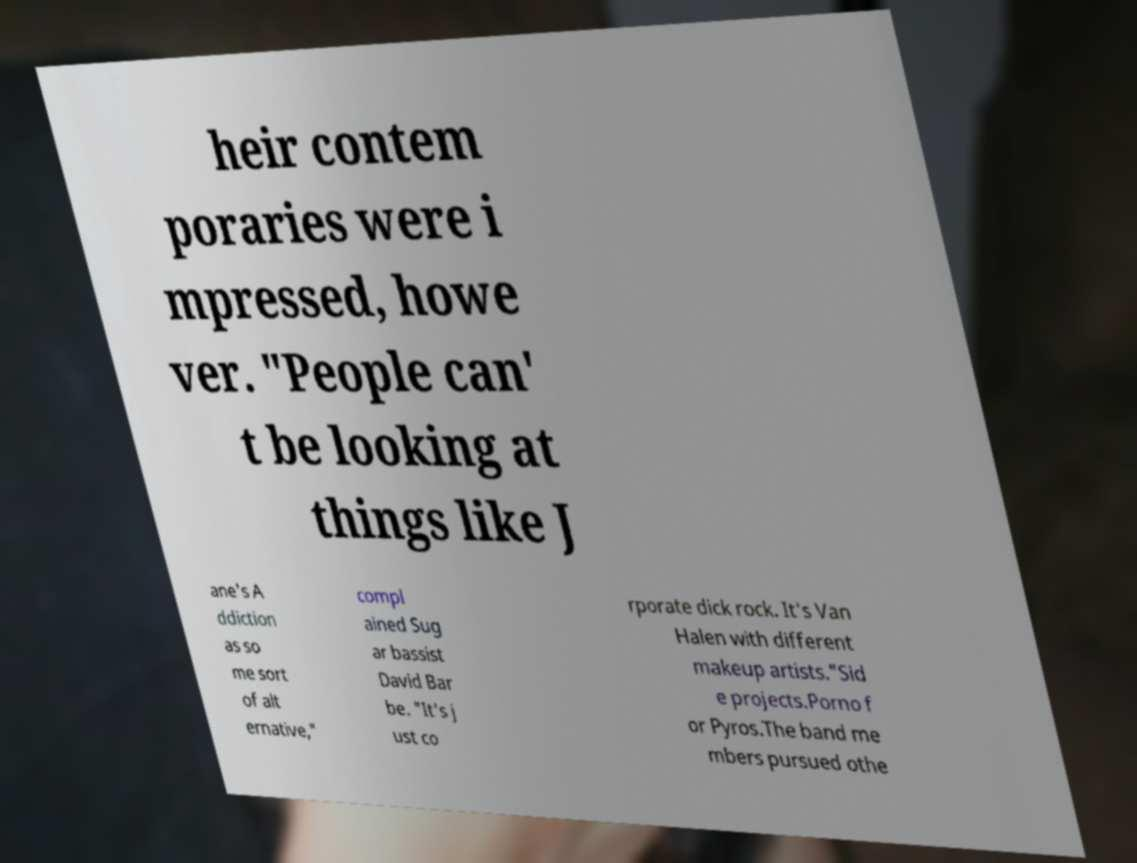There's text embedded in this image that I need extracted. Can you transcribe it verbatim? heir contem poraries were i mpressed, howe ver. "People can' t be looking at things like J ane's A ddiction as so me sort of alt ernative," compl ained Sug ar bassist David Bar be. "It's j ust co rporate dick rock. It's Van Halen with different makeup artists."Sid e projects.Porno f or Pyros.The band me mbers pursued othe 